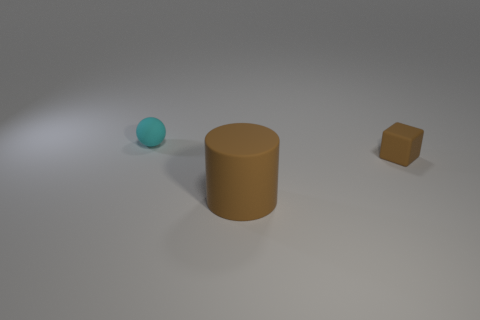What material is the small thing in front of the thing left of the large brown cylinder?
Give a very brief answer. Rubber. What color is the large cylinder?
Your answer should be very brief. Brown. There is a small cyan ball that is to the left of the large matte thing; is there a brown rubber thing that is in front of it?
Give a very brief answer. Yes. What material is the small cyan object?
Give a very brief answer. Rubber. Do the small thing that is right of the cyan rubber thing and the thing that is left of the matte cylinder have the same material?
Make the answer very short. Yes. Are there any other things that have the same color as the matte ball?
Make the answer very short. No. What is the size of the rubber object that is on the left side of the tiny brown object and to the right of the rubber ball?
Your answer should be compact. Large. There is a tiny object that is in front of the matte ball; does it have the same shape as the small thing left of the brown block?
Your answer should be very brief. No. There is a tiny object that is the same color as the big cylinder; what shape is it?
Keep it short and to the point. Cube. How many small balls have the same material as the big brown cylinder?
Your response must be concise. 1. 